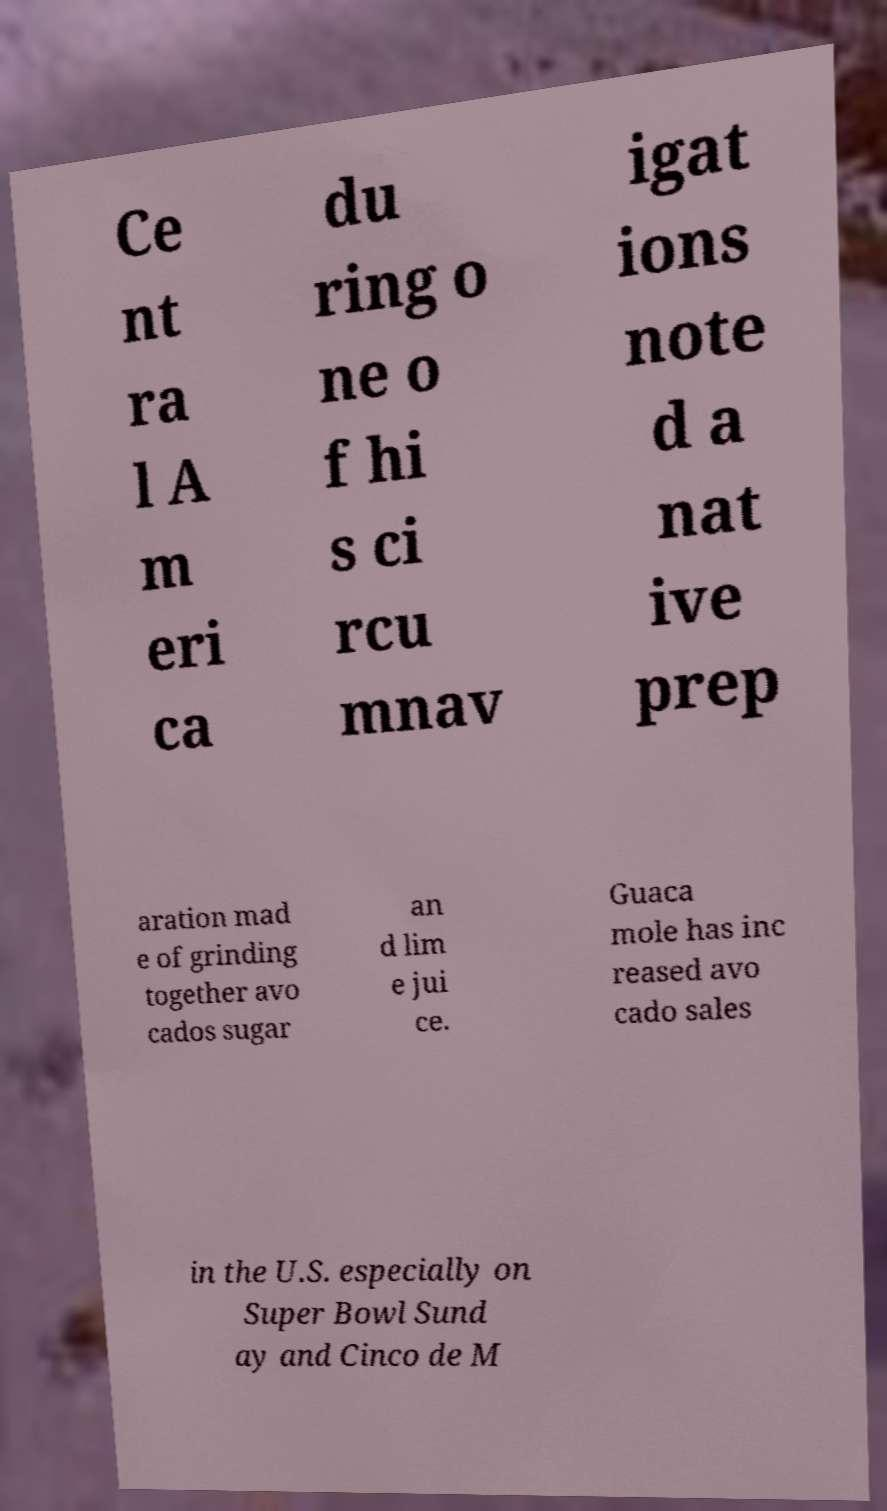There's text embedded in this image that I need extracted. Can you transcribe it verbatim? Ce nt ra l A m eri ca du ring o ne o f hi s ci rcu mnav igat ions note d a nat ive prep aration mad e of grinding together avo cados sugar an d lim e jui ce. Guaca mole has inc reased avo cado sales in the U.S. especially on Super Bowl Sund ay and Cinco de M 